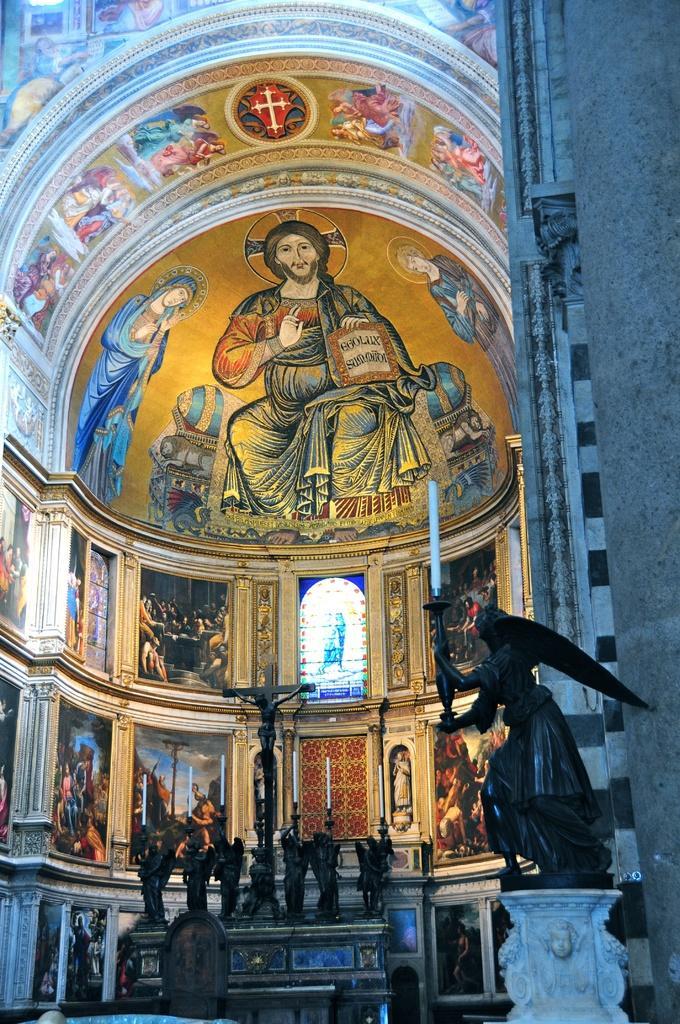In one or two sentences, can you explain what this image depicts? In this image, I can see the paintings of the people and a holy cross symbol on a wall. At the bottom of the image, there are sculptures and candles. On the right side of the image, It looks like a pillar. 